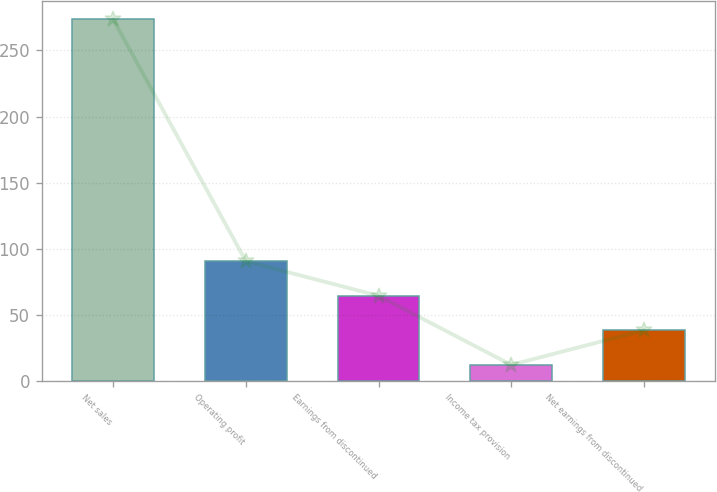Convert chart. <chart><loc_0><loc_0><loc_500><loc_500><bar_chart><fcel>Net sales<fcel>Operating profit<fcel>Earnings from discontinued<fcel>Income tax provision<fcel>Net earnings from discontinued<nl><fcel>273.5<fcel>90.52<fcel>64.38<fcel>12.1<fcel>38.24<nl></chart> 